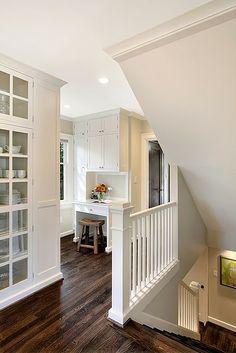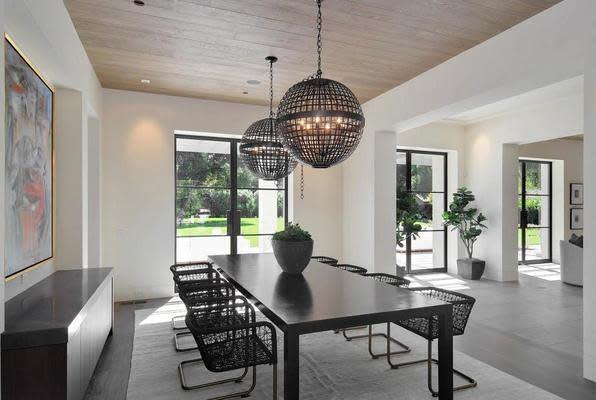The first image is the image on the left, the second image is the image on the right. Examine the images to the left and right. Is the description "There is a curved staircase." accurate? Answer yes or no. No. The first image is the image on the left, the second image is the image on the right. Considering the images on both sides, is "The stairs in each image are going up toward the other image." valid? Answer yes or no. No. 